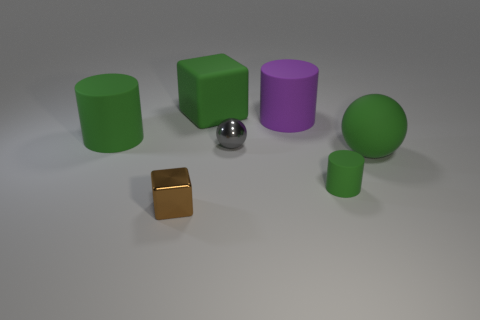What color is the tiny sphere?
Give a very brief answer. Gray. What number of other things are the same color as the small metal block?
Keep it short and to the point. 0. There is a brown block; are there any things left of it?
Your answer should be very brief. Yes. There is a matte object that is left of the large green rubber thing that is behind the matte object to the left of the brown block; what is its color?
Make the answer very short. Green. What number of green things are left of the green matte cube and in front of the small gray object?
Your response must be concise. 0. What number of cylinders are small gray objects or large things?
Ensure brevity in your answer.  2. Are any tiny red cylinders visible?
Provide a succinct answer. No. How many other things are the same material as the purple thing?
Provide a short and direct response. 4. There is a green cylinder that is the same size as the green rubber sphere; what material is it?
Your answer should be compact. Rubber. Does the big thing to the right of the big purple object have the same shape as the tiny gray thing?
Provide a short and direct response. Yes. 